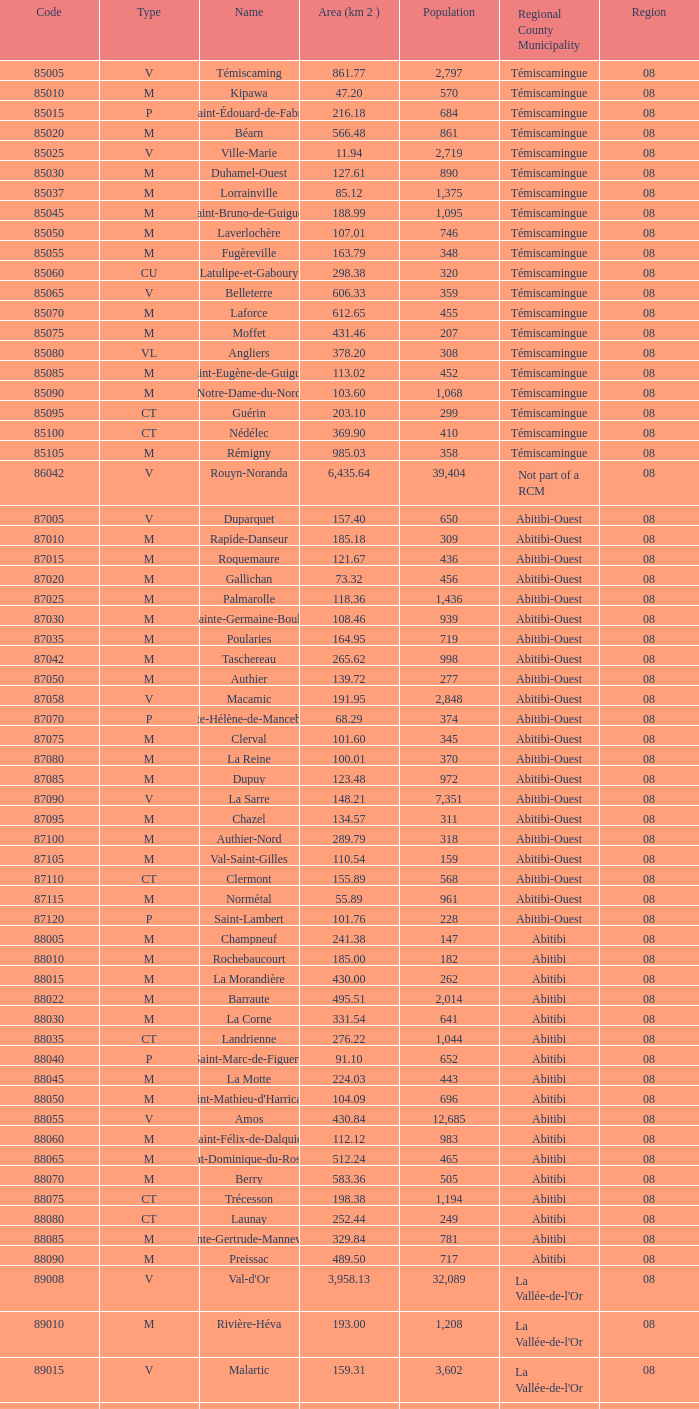What was the area of 159.31 km2 associated with the malartic region? 0.0. 